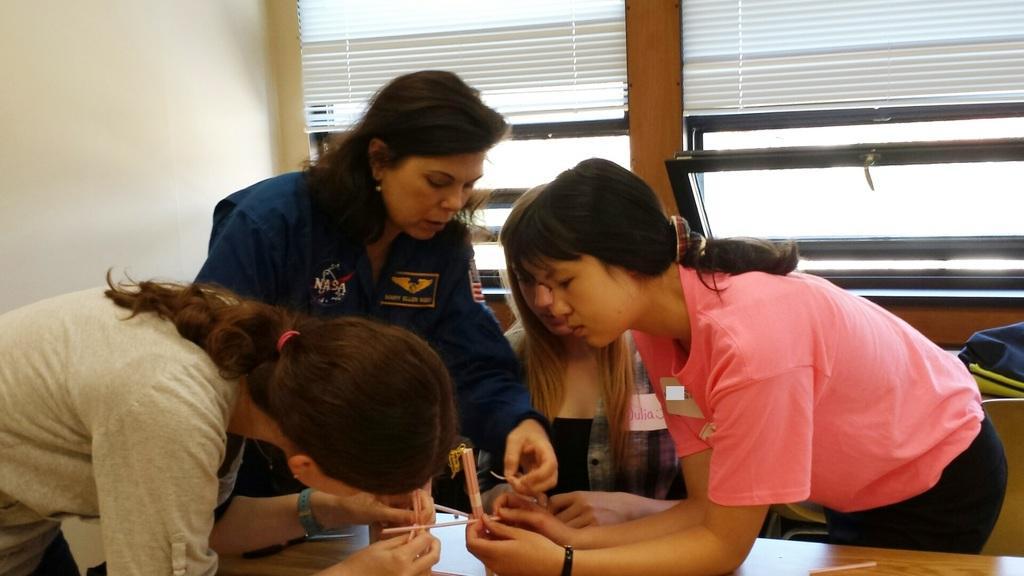Please provide a concise description of this image. In this image I can see the group of people with different color dresses. These people are in-front of the table and I can see these people are holding some objects. To the right I can see the navy blue and yellow color object. In the background I can see the wall and the window blind. 